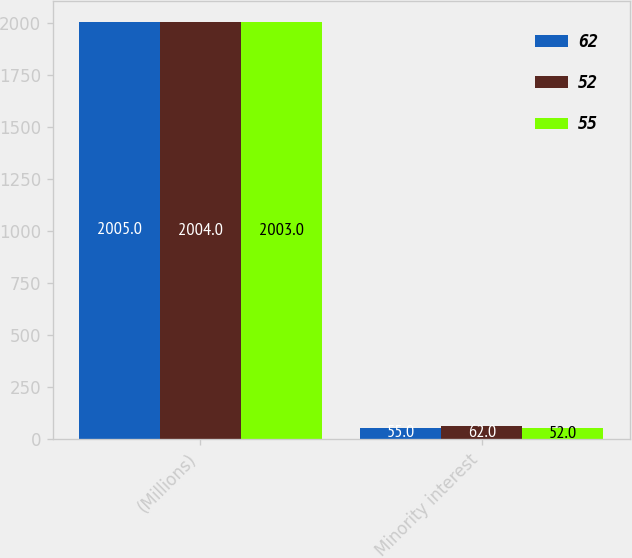Convert chart to OTSL. <chart><loc_0><loc_0><loc_500><loc_500><stacked_bar_chart><ecel><fcel>(Millions)<fcel>Minority interest<nl><fcel>62<fcel>2005<fcel>55<nl><fcel>52<fcel>2004<fcel>62<nl><fcel>55<fcel>2003<fcel>52<nl></chart> 